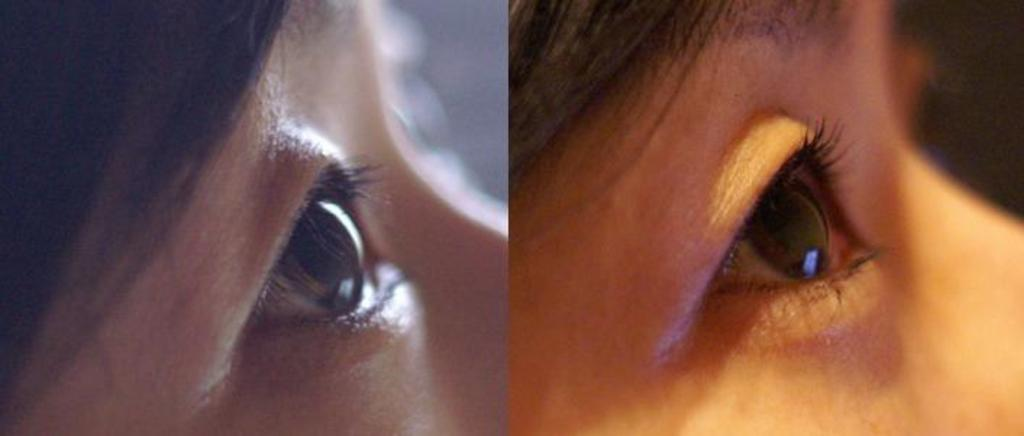How many images are combined in the collage? The collage is a combination of two images. Can you describe the appearance of the images in the collage? One image appears dim, while the other image appears bright. What subject matter is depicted in the images? Both images are of a woman's eyes. Where is the nest located in the image? There is no nest present in the image; it is a collage of two images of a woman's eyes. What type of bird can be seen sitting on the robin in the image? There is no bird or robin present in the image; it is a collage of two images of a woman's eyes. 